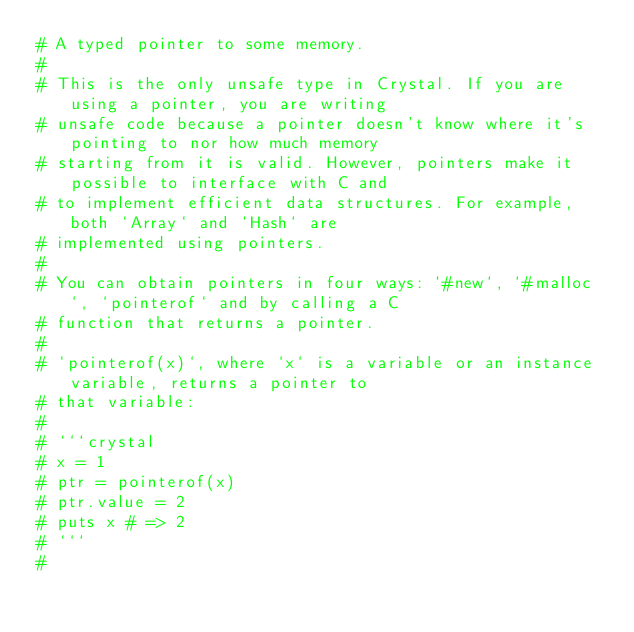<code> <loc_0><loc_0><loc_500><loc_500><_Crystal_># A typed pointer to some memory.
#
# This is the only unsafe type in Crystal. If you are using a pointer, you are writing
# unsafe code because a pointer doesn't know where it's pointing to nor how much memory
# starting from it is valid. However, pointers make it possible to interface with C and
# to implement efficient data structures. For example, both `Array` and `Hash` are
# implemented using pointers.
#
# You can obtain pointers in four ways: `#new`, `#malloc`, `pointerof` and by calling a C
# function that returns a pointer.
#
# `pointerof(x)`, where `x` is a variable or an instance variable, returns a pointer to
# that variable:
#
# ```crystal
# x = 1
# ptr = pointerof(x)
# ptr.value = 2
# puts x # => 2
# ```
#</code> 